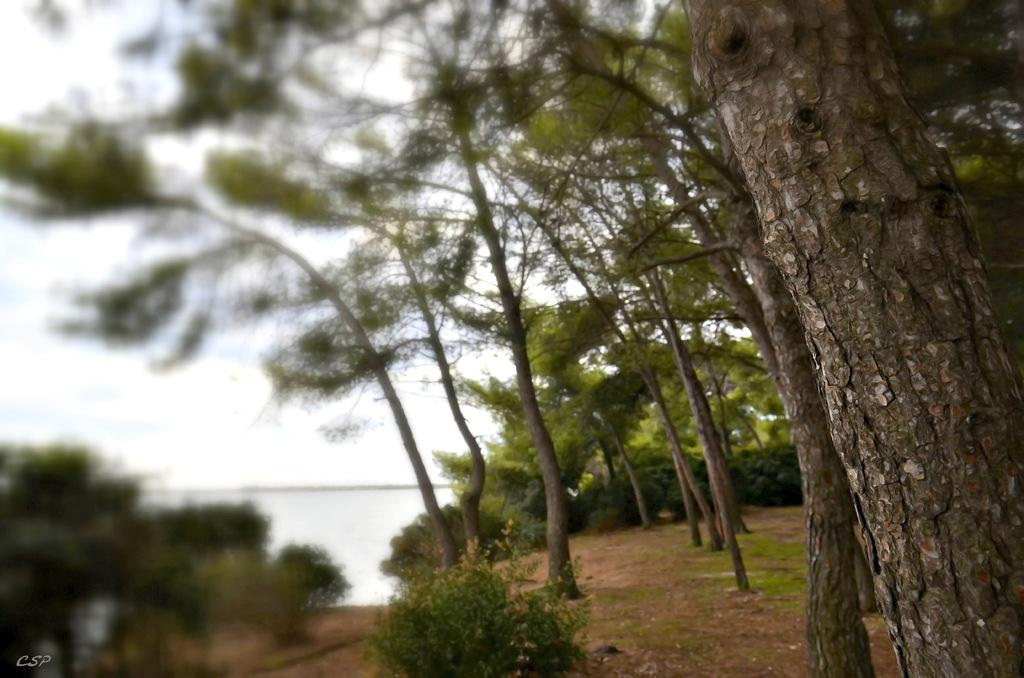What type of vegetation can be seen in the image? There are tall trees in the image. How are the trees arranged in the image? The trees are arranged one beside the other on the ground. What can be seen in the background of the image? There is water visible in the background of the image. What type of support does the mind receive from the trees in the image? The image does not depict any interaction between the trees and the mind, so it is not possible to determine the type of support provided. 